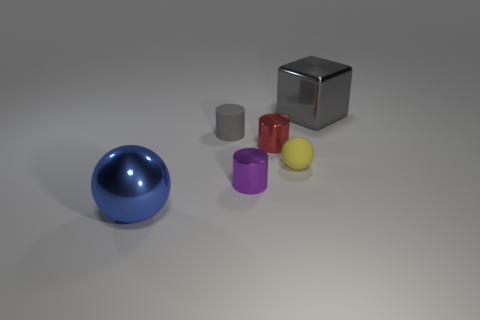Do the objects look like they're made from the same material? The objects have varied appearances suggesting different materials. The blue sphere and silver cube have reflective surfaces, indicating they might be metallic. The yellow, purple, and red cylinders have more of a matte finish, possibly plastic or painted metal. 